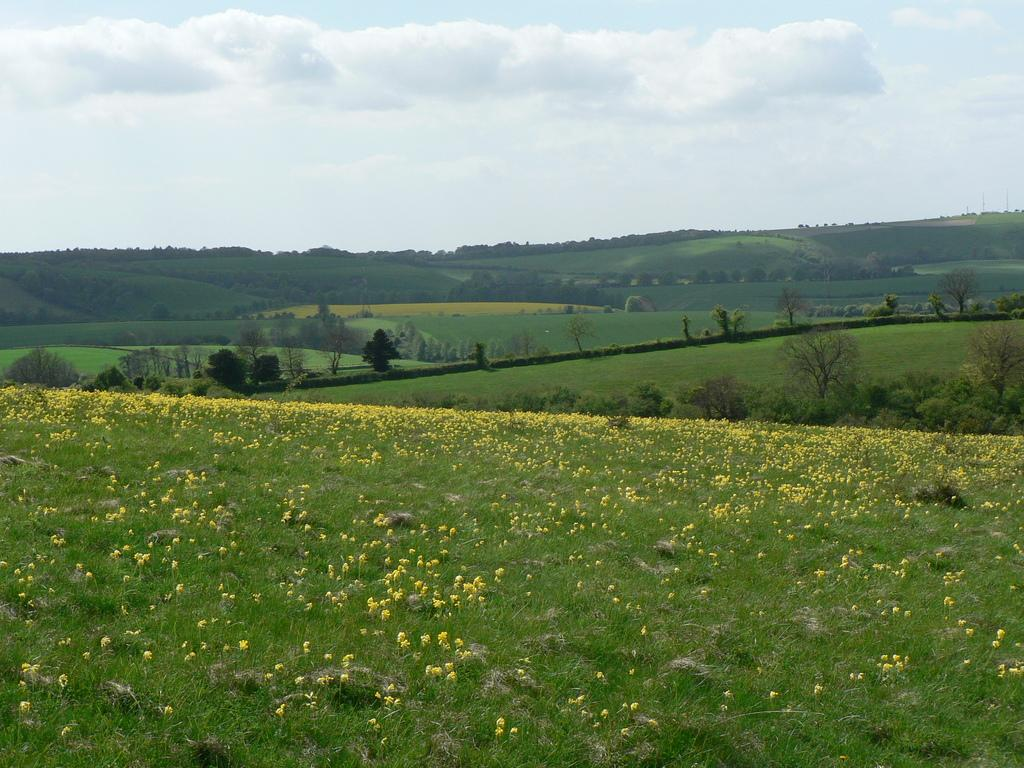What type of flowers can be seen in the image? There are yellow flowers in the image. What type of vegetation is present in the image? There is grass and stones visible in the image. What can be seen in the background of the image? There are trees and greenery visible in the background. How would you describe the sky in the image? The sky is cloudy in the image. What type of company does the partner own, as seen in the image? There is no information about a company or partner in the image; it features yellow flowers, grass, stones, trees, greenery, and a cloudy sky. 